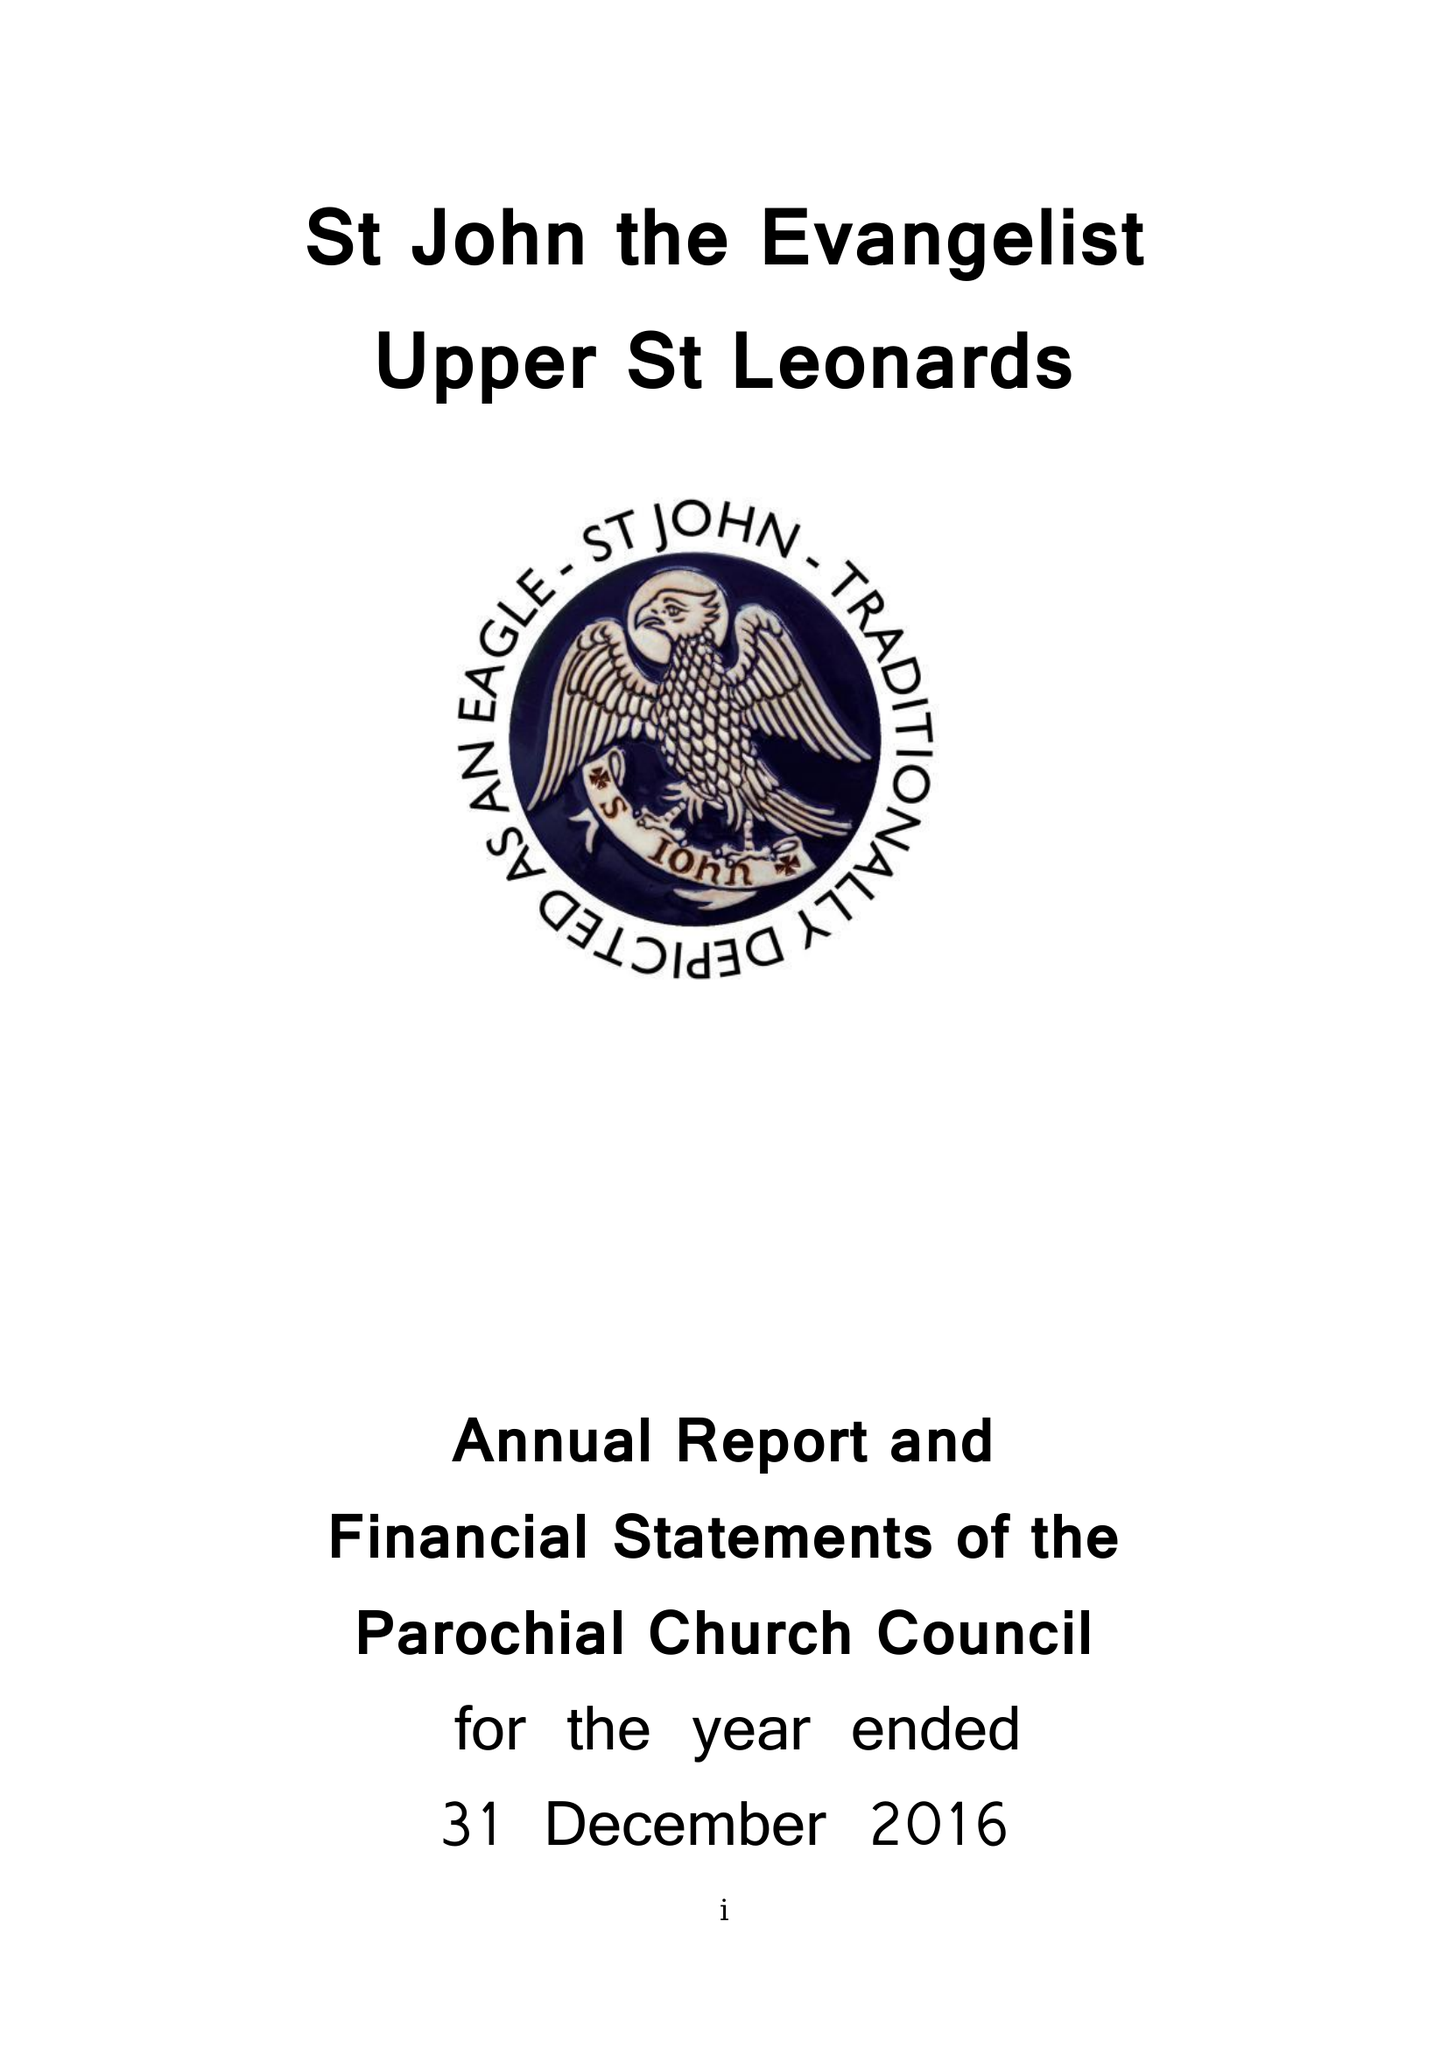What is the value for the income_annually_in_british_pounds?
Answer the question using a single word or phrase. 121942.00 